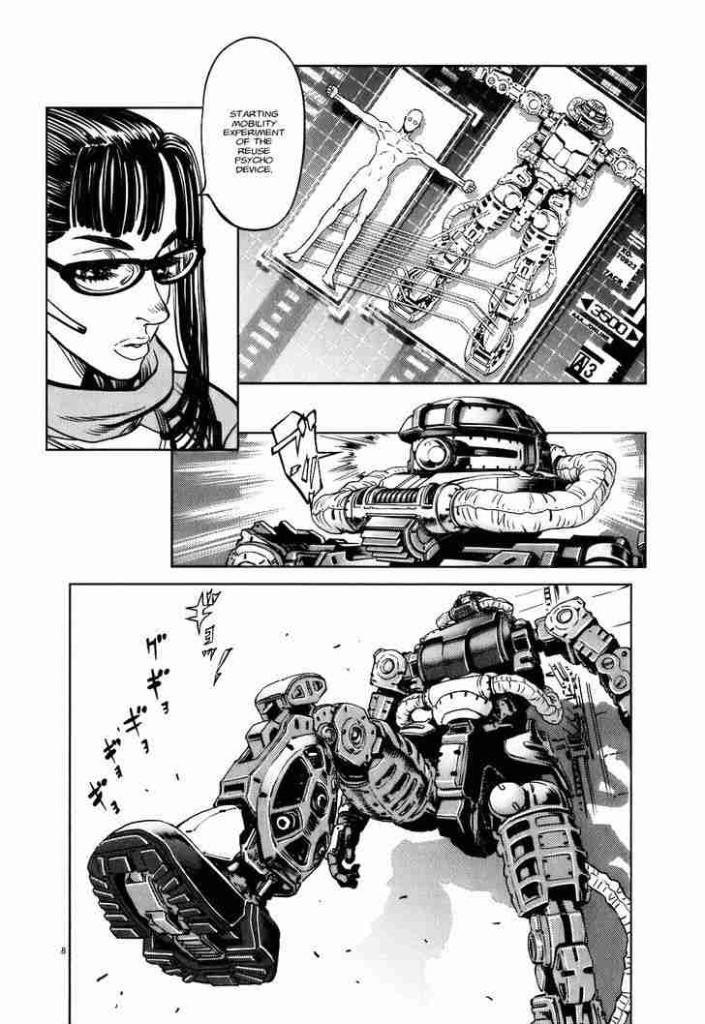What can be observed about the nature of the image? The image is edited. What subjects are depicted in the image? There are pictures of robots and a woman in the image. What is present in the image to convey information or context? There is text in the image. What color is the background of the image? The background of the image is white. What flavor of ice cream does the woman in the image prefer? There is no information about the woman's ice cream preferences in the image, as it does not contain any ice cream or related context. 